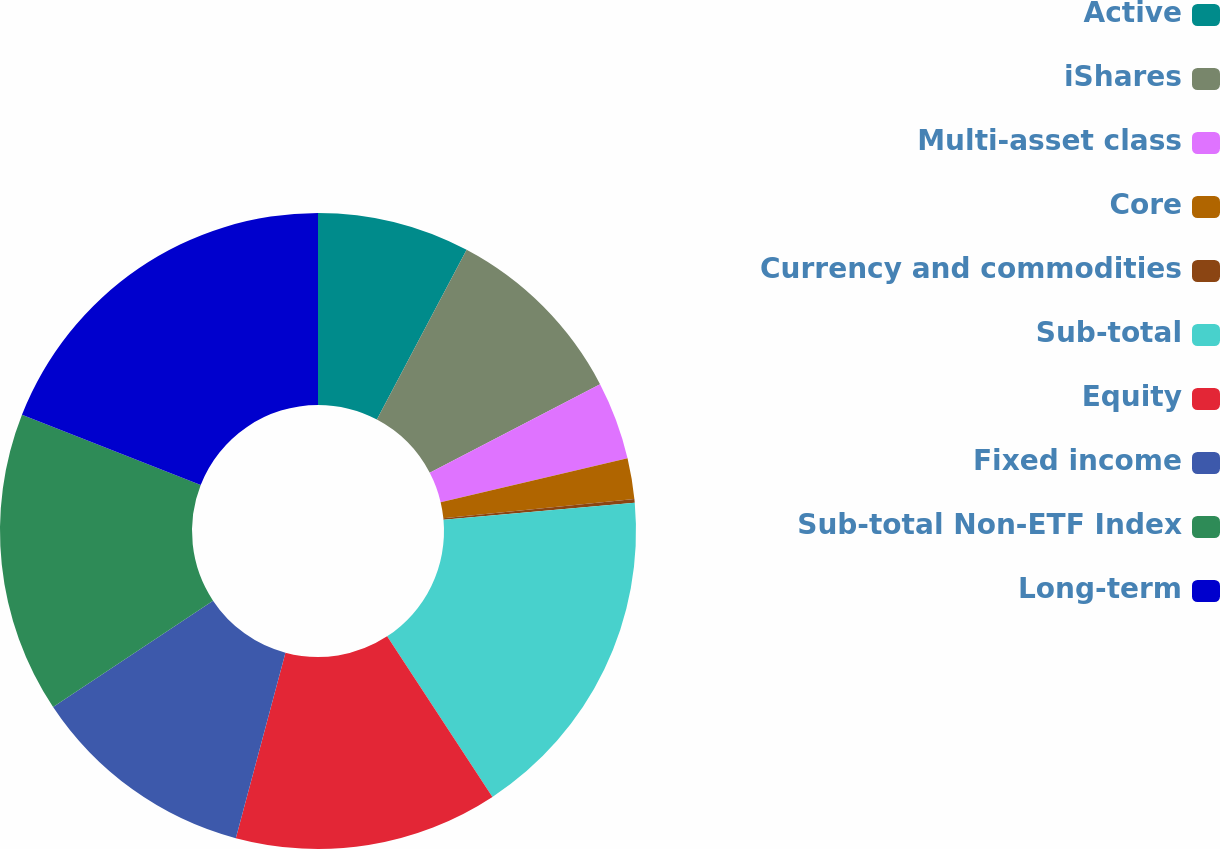Convert chart to OTSL. <chart><loc_0><loc_0><loc_500><loc_500><pie_chart><fcel>Active<fcel>iShares<fcel>Multi-asset class<fcel>Core<fcel>Currency and commodities<fcel>Sub-total<fcel>Equity<fcel>Fixed income<fcel>Sub-total Non-ETF Index<fcel>Long-term<nl><fcel>7.74%<fcel>9.62%<fcel>3.96%<fcel>2.08%<fcel>0.19%<fcel>17.17%<fcel>13.4%<fcel>11.51%<fcel>15.28%<fcel>19.05%<nl></chart> 